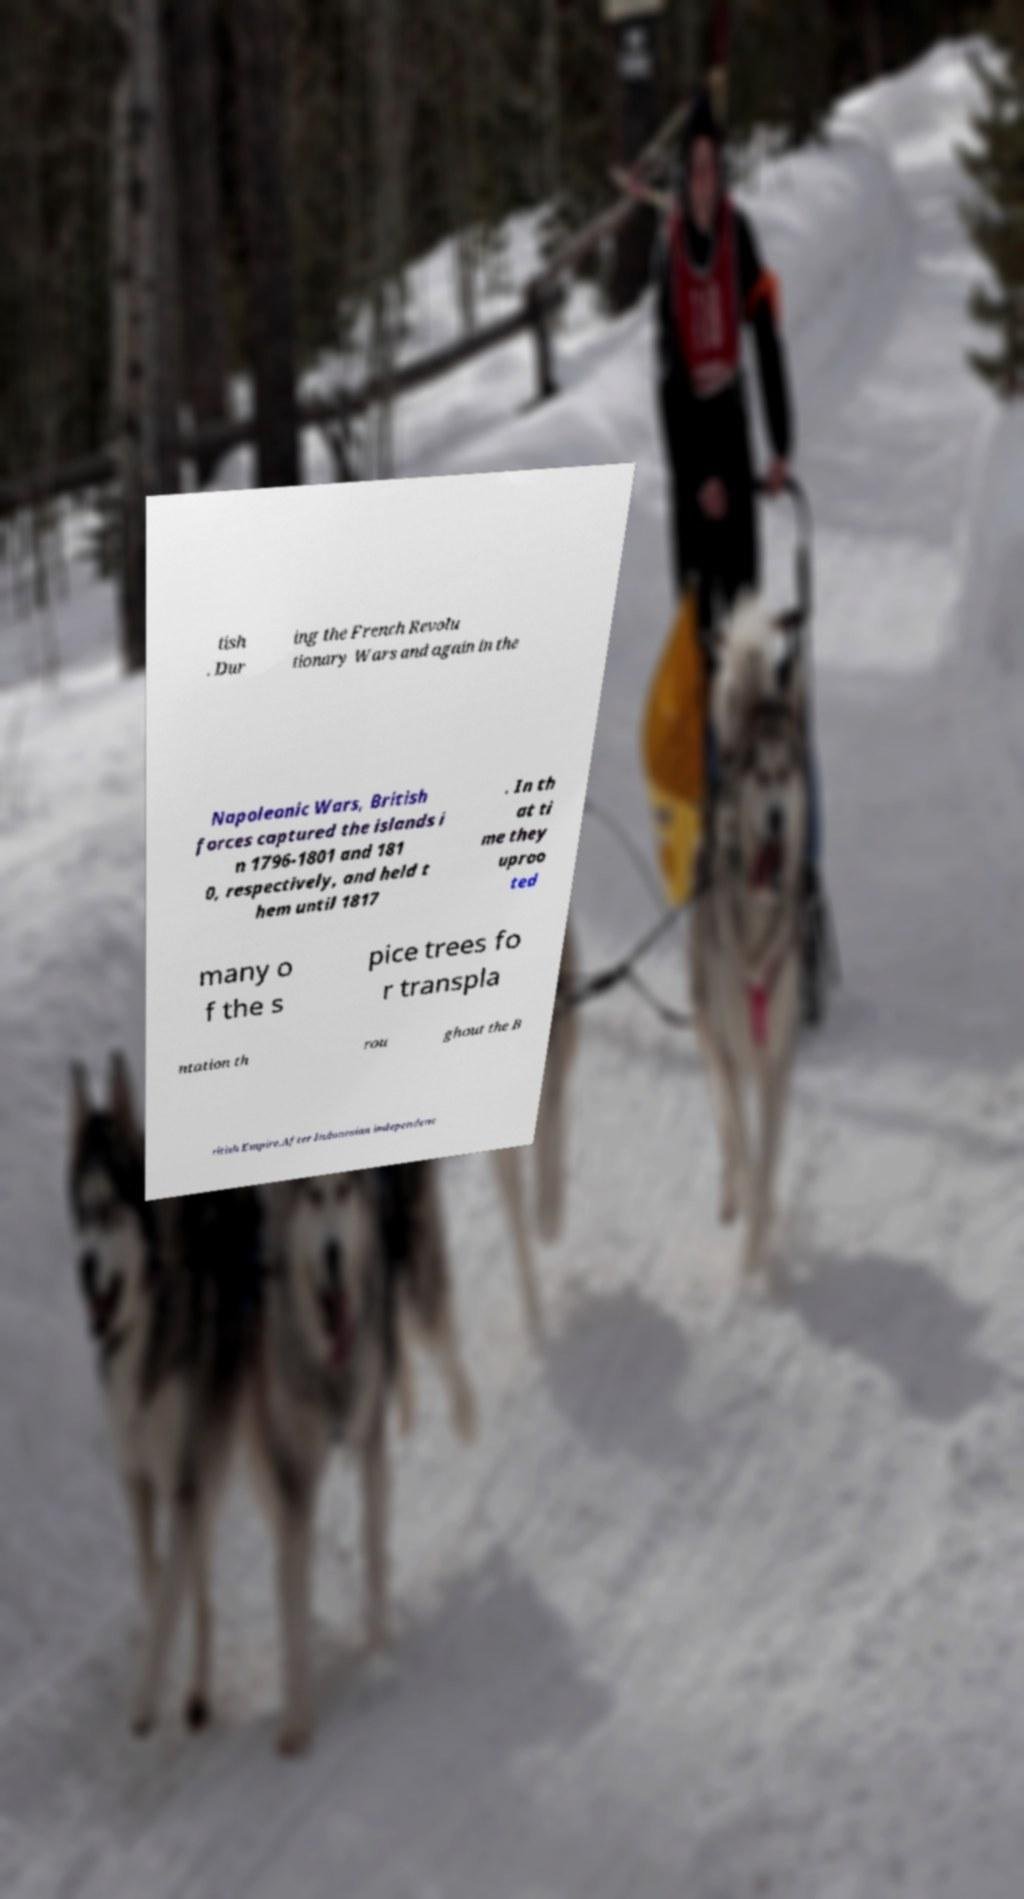Could you assist in decoding the text presented in this image and type it out clearly? tish . Dur ing the French Revolu tionary Wars and again in the Napoleonic Wars, British forces captured the islands i n 1796-1801 and 181 0, respectively, and held t hem until 1817 . In th at ti me they uproo ted many o f the s pice trees fo r transpla ntation th rou ghout the B ritish Empire.After Indonesian independenc 